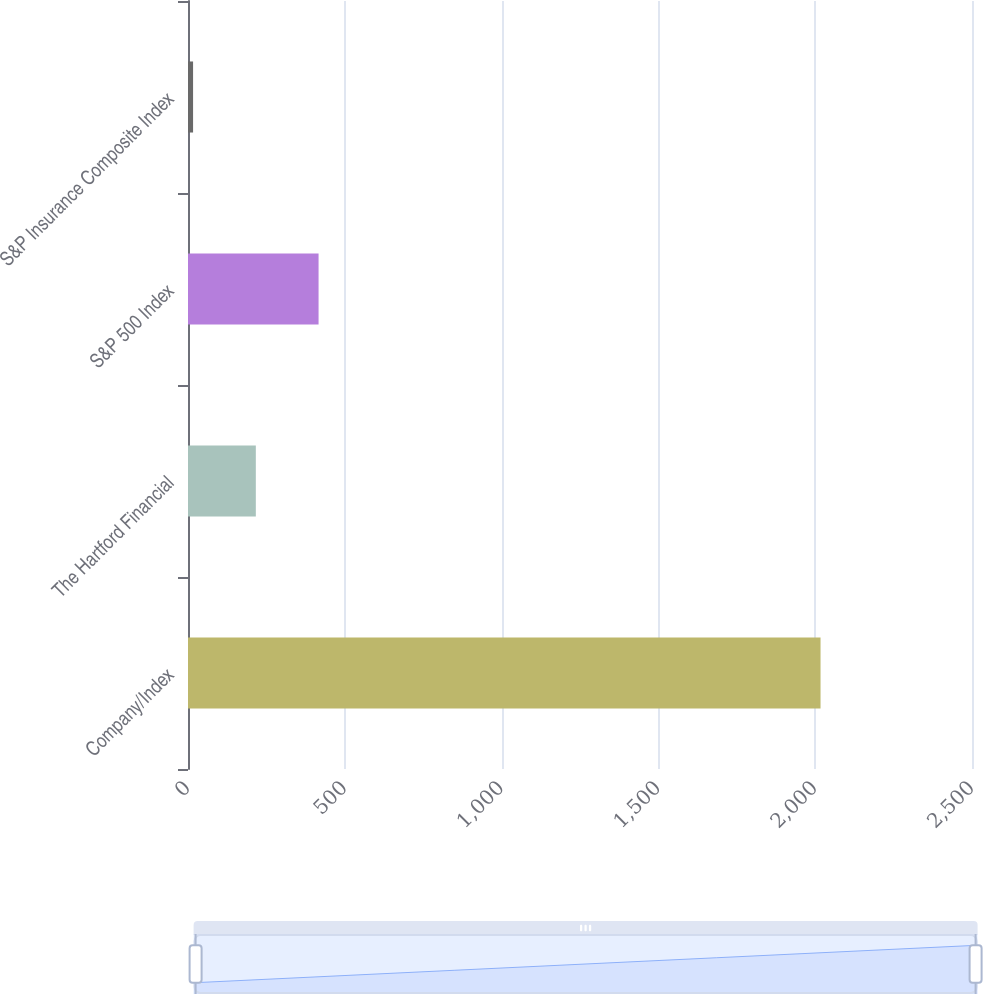Convert chart to OTSL. <chart><loc_0><loc_0><loc_500><loc_500><bar_chart><fcel>Company/Index<fcel>The Hartford Financial<fcel>S&P 500 Index<fcel>S&P Insurance Composite Index<nl><fcel>2017<fcel>216.27<fcel>416.35<fcel>16.19<nl></chart> 